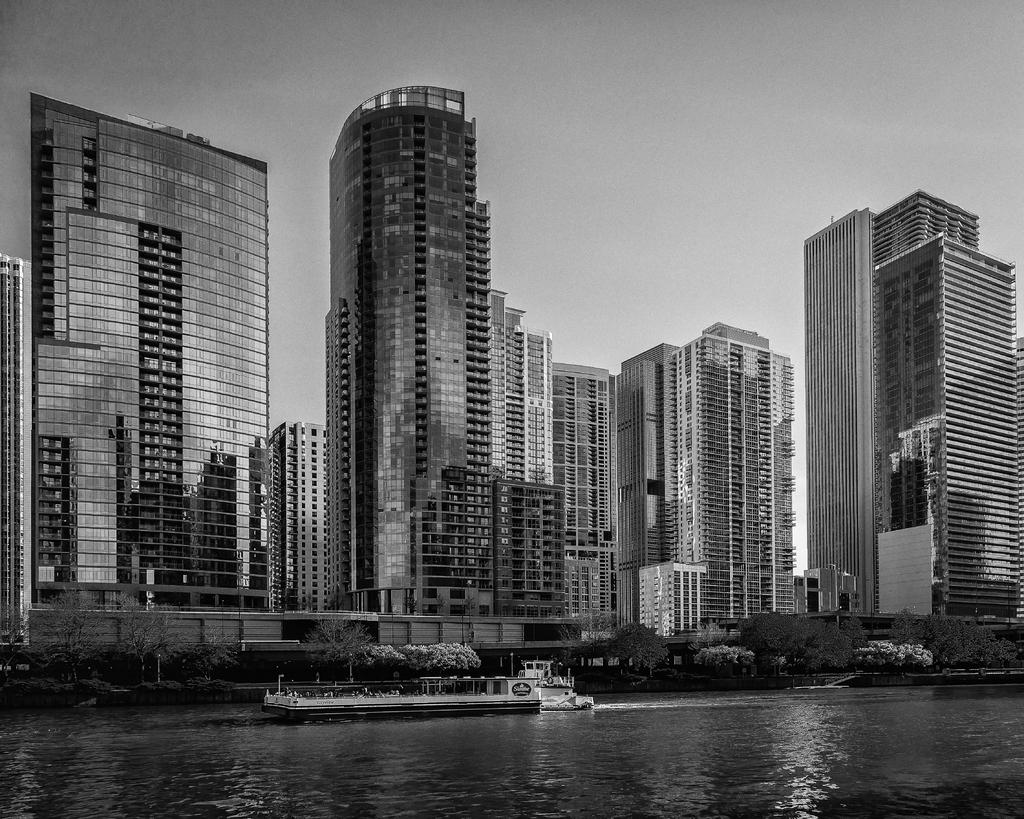What is the color scheme of the image? The image is black and white. What can be seen on the water in the image? There are boats on the water in the image. What type of structures are present in the image? There are buildings in the image. What other natural elements can be seen in the image? There are trees in the image. What is visible in the background of the image? The sky is visible in the background of the image. What type of plantation is depicted in the image? There is no plantation present in the image; it features boats on the water, buildings, trees, and a sky background. What do the boats believe about the trees in the image? The boats cannot have beliefs, as they are inanimate objects. 